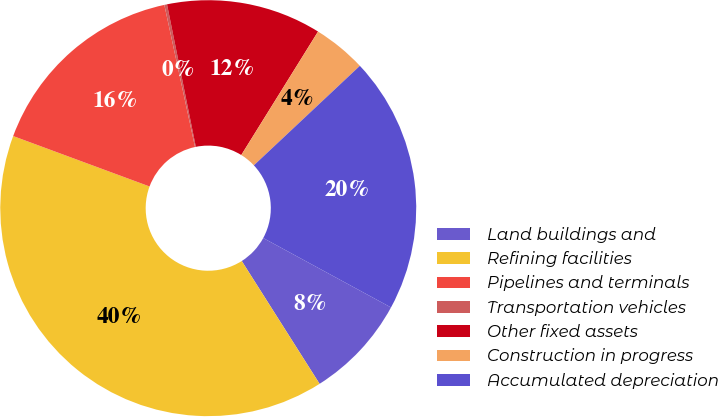<chart> <loc_0><loc_0><loc_500><loc_500><pie_chart><fcel>Land buildings and<fcel>Refining facilities<fcel>Pipelines and terminals<fcel>Transportation vehicles<fcel>Other fixed assets<fcel>Construction in progress<fcel>Accumulated depreciation<nl><fcel>8.09%<fcel>39.63%<fcel>15.98%<fcel>0.21%<fcel>12.03%<fcel>4.15%<fcel>19.92%<nl></chart> 